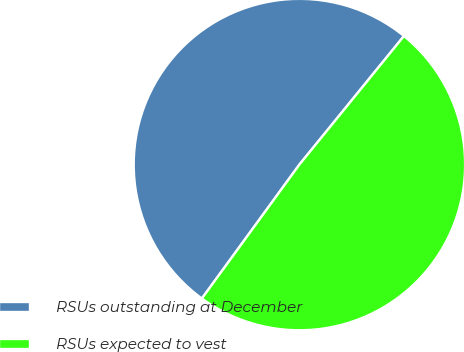Convert chart. <chart><loc_0><loc_0><loc_500><loc_500><pie_chart><fcel>RSUs outstanding at December<fcel>RSUs expected to vest<nl><fcel>50.85%<fcel>49.15%<nl></chart> 